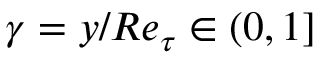<formula> <loc_0><loc_0><loc_500><loc_500>\gamma = y / R e _ { \tau } \in ( 0 , 1 ]</formula> 